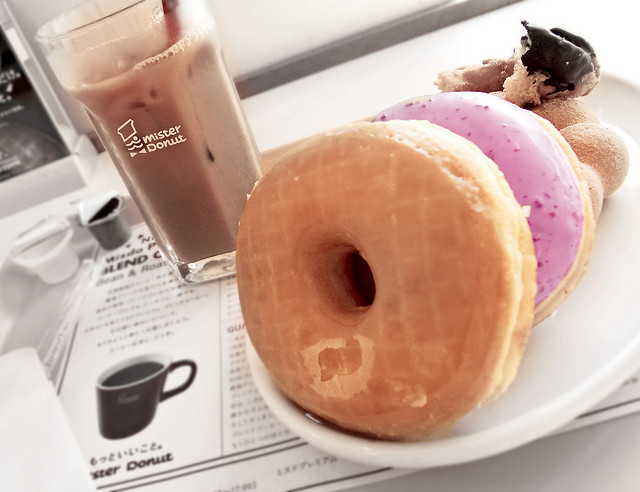Identify the text contained in this image. mister mister donut Donue 